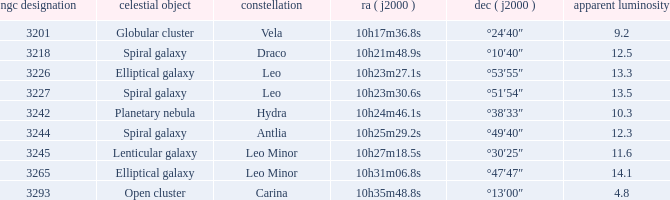What is the sum of NGC numbers for Constellation vela? 3201.0. 